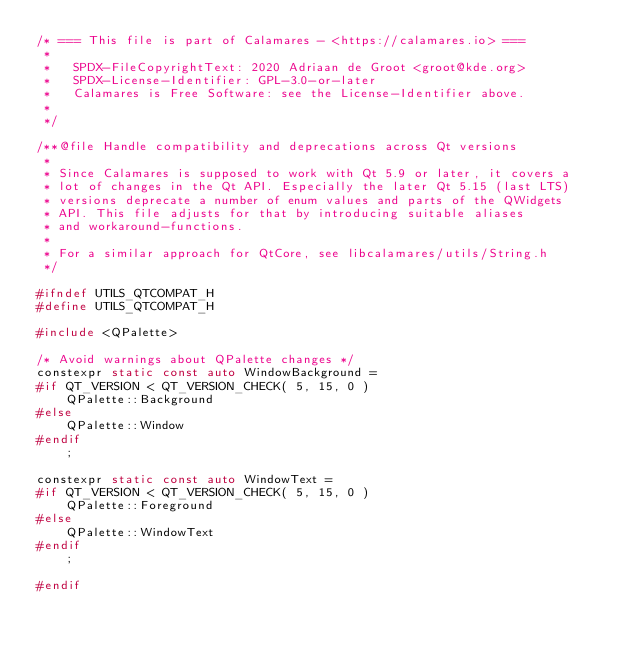Convert code to text. <code><loc_0><loc_0><loc_500><loc_500><_C_>/* === This file is part of Calamares - <https://calamares.io> ===
 *
 *   SPDX-FileCopyrightText: 2020 Adriaan de Groot <groot@kde.org>
 *   SPDX-License-Identifier: GPL-3.0-or-later
 *   Calamares is Free Software: see the License-Identifier above.
 *
 */

/**@file Handle compatibility and deprecations across Qt versions
 *
 * Since Calamares is supposed to work with Qt 5.9 or later, it covers a
 * lot of changes in the Qt API. Especially the later Qt 5.15 (last LTS)
 * versions deprecate a number of enum values and parts of the QWidgets
 * API. This file adjusts for that by introducing suitable aliases
 * and workaround-functions.
 *
 * For a similar approach for QtCore, see libcalamares/utils/String.h
 */

#ifndef UTILS_QTCOMPAT_H
#define UTILS_QTCOMPAT_H

#include <QPalette>

/* Avoid warnings about QPalette changes */
constexpr static const auto WindowBackground =
#if QT_VERSION < QT_VERSION_CHECK( 5, 15, 0 )
    QPalette::Background
#else
    QPalette::Window
#endif
    ;

constexpr static const auto WindowText =
#if QT_VERSION < QT_VERSION_CHECK( 5, 15, 0 )
    QPalette::Foreground
#else
    QPalette::WindowText
#endif
    ;

#endif
</code> 